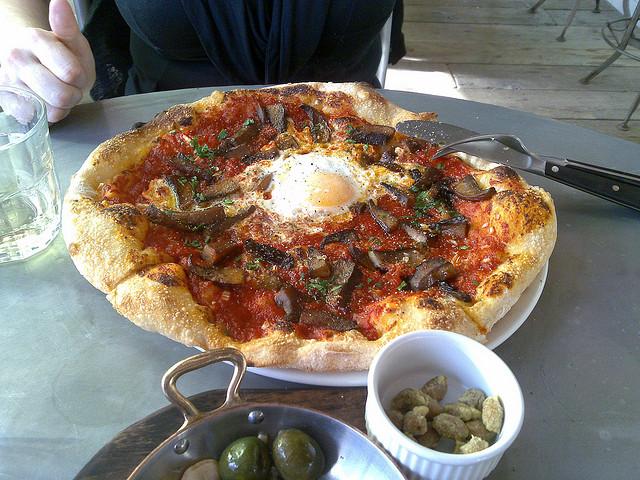What is in the middle of the pizza?
Be succinct. Egg. Are they olives in the lower center of this scene?
Answer briefly. Yes. Where is the fork?
Concise answer only. Pizza. What color is the pizza plate?
Give a very brief answer. White. 